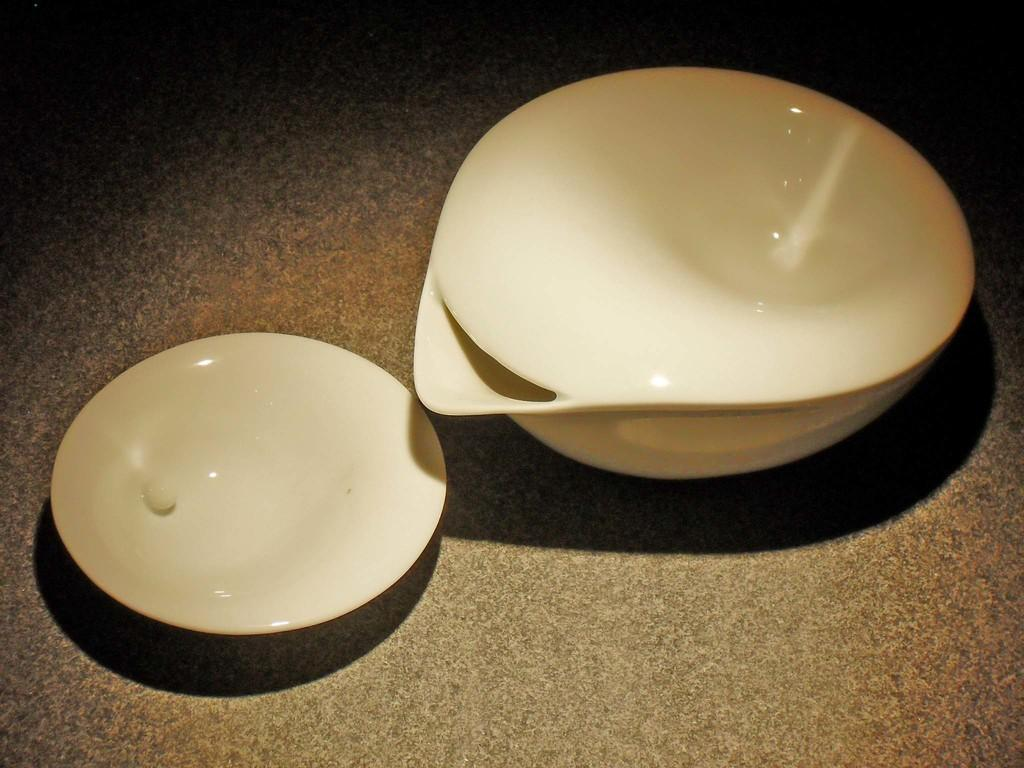What is present on the platform in the image? There is a bowl and a plate on the platform in the image. What is the purpose of the bowl in the image? The purpose of the bowl in the image is not specified, but it could be used for holding food or other items. What is the purpose of the plate in the image? The purpose of the plate in the image is not specified, but it could also be used for holding food or other items. How many rabbits can be seen jumping through the hole in the image? There is no hole or rabbits present in the image. 